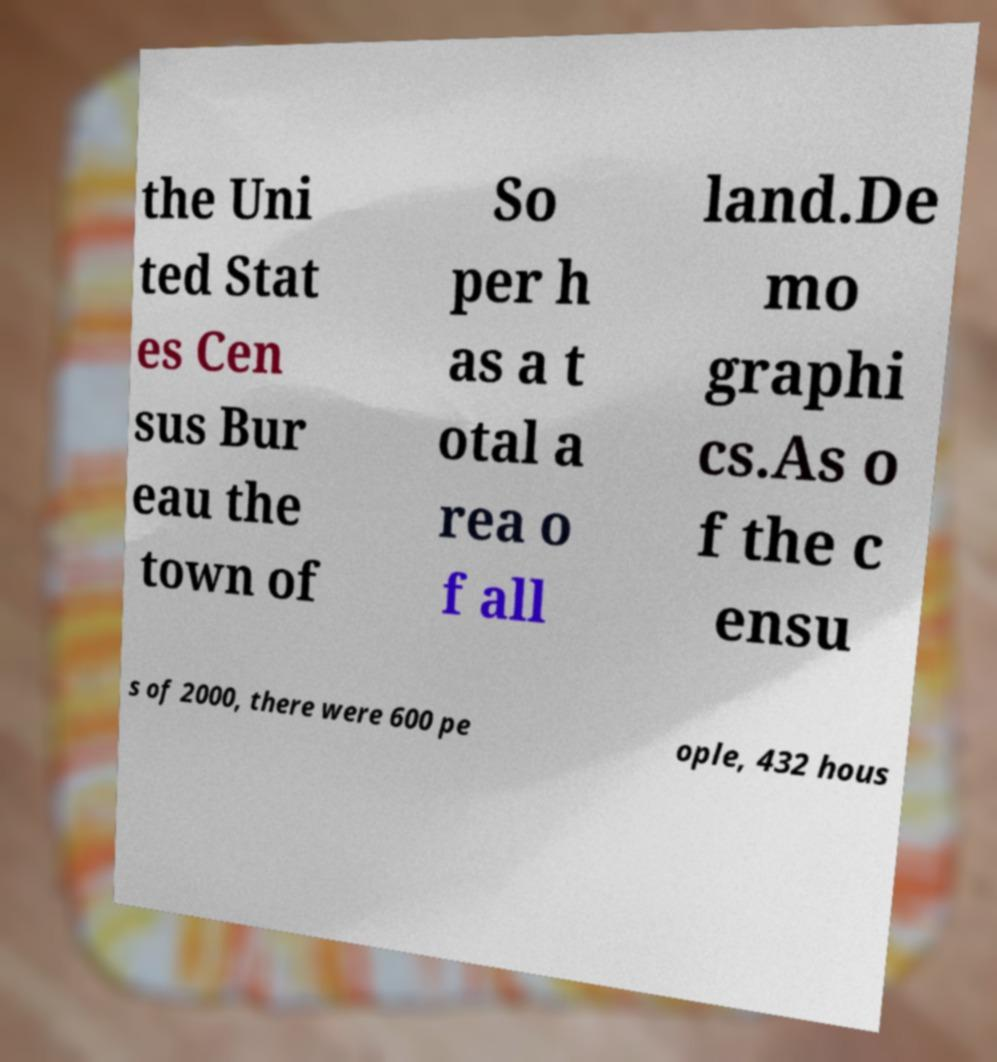Can you accurately transcribe the text from the provided image for me? the Uni ted Stat es Cen sus Bur eau the town of So per h as a t otal a rea o f all land.De mo graphi cs.As o f the c ensu s of 2000, there were 600 pe ople, 432 hous 